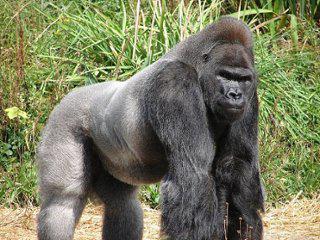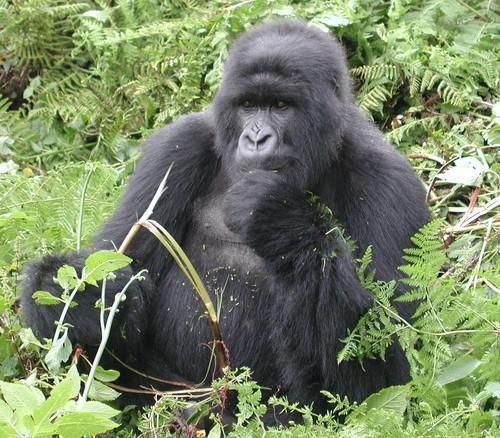The first image is the image on the left, the second image is the image on the right. Given the left and right images, does the statement "The gorilla in the image on the left is touching the ground with both of it's arms." hold true? Answer yes or no. Yes. 